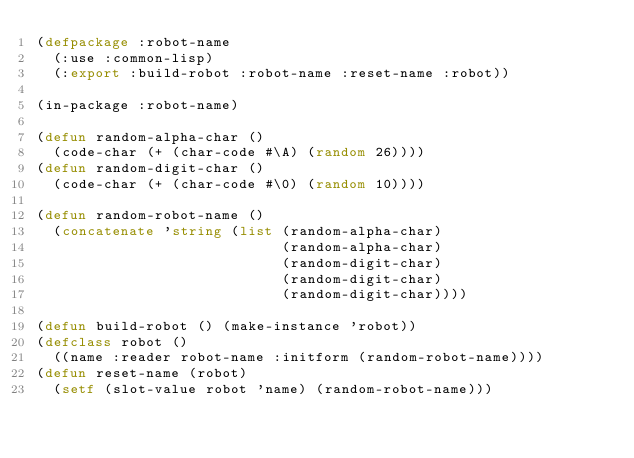Convert code to text. <code><loc_0><loc_0><loc_500><loc_500><_Lisp_>(defpackage :robot-name
  (:use :common-lisp)
  (:export :build-robot :robot-name :reset-name :robot))

(in-package :robot-name)

(defun random-alpha-char ()
  (code-char (+ (char-code #\A) (random 26))))
(defun random-digit-char ()
  (code-char (+ (char-code #\0) (random 10))))

(defun random-robot-name ()
  (concatenate 'string (list (random-alpha-char)
                             (random-alpha-char)
                             (random-digit-char)
                             (random-digit-char)
                             (random-digit-char))))

(defun build-robot () (make-instance 'robot))
(defclass robot ()
  ((name :reader robot-name :initform (random-robot-name))))
(defun reset-name (robot)
  (setf (slot-value robot 'name) (random-robot-name)))
</code> 